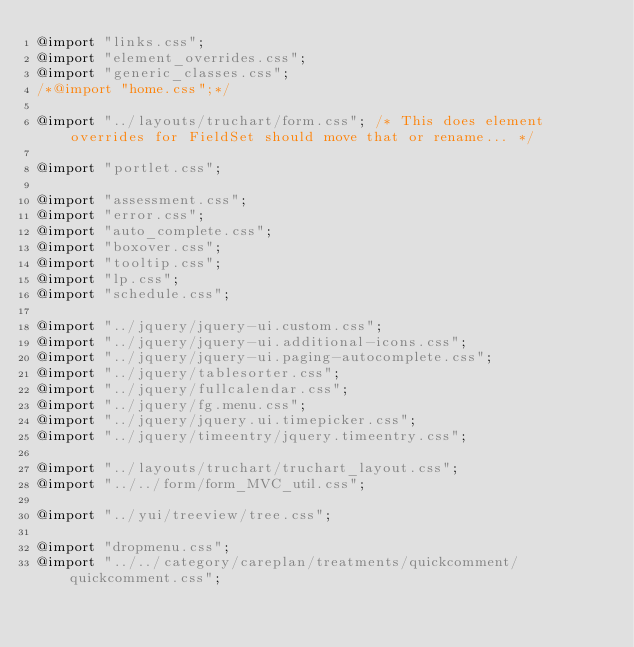<code> <loc_0><loc_0><loc_500><loc_500><_CSS_>@import "links.css";
@import "element_overrides.css";
@import "generic_classes.css";
/*@import "home.css";*/

@import "../layouts/truchart/form.css"; /* This does element overrides for FieldSet should move that or rename... */

@import "portlet.css";

@import "assessment.css";
@import "error.css";
@import "auto_complete.css";
@import "boxover.css";
@import "tooltip.css";
@import "lp.css";
@import "schedule.css";

@import "../jquery/jquery-ui.custom.css";
@import "../jquery/jquery-ui.additional-icons.css";
@import "../jquery/jquery-ui.paging-autocomplete.css";
@import "../jquery/tablesorter.css";
@import "../jquery/fullcalendar.css";
@import "../jquery/fg.menu.css";
@import "../jquery/jquery.ui.timepicker.css";
@import "../jquery/timeentry/jquery.timeentry.css";

@import "../layouts/truchart/truchart_layout.css";
@import "../../form/form_MVC_util.css";

@import "../yui/treeview/tree.css";

@import "dropmenu.css";
@import "../../category/careplan/treatments/quickcomment/quickcomment.css";
</code> 